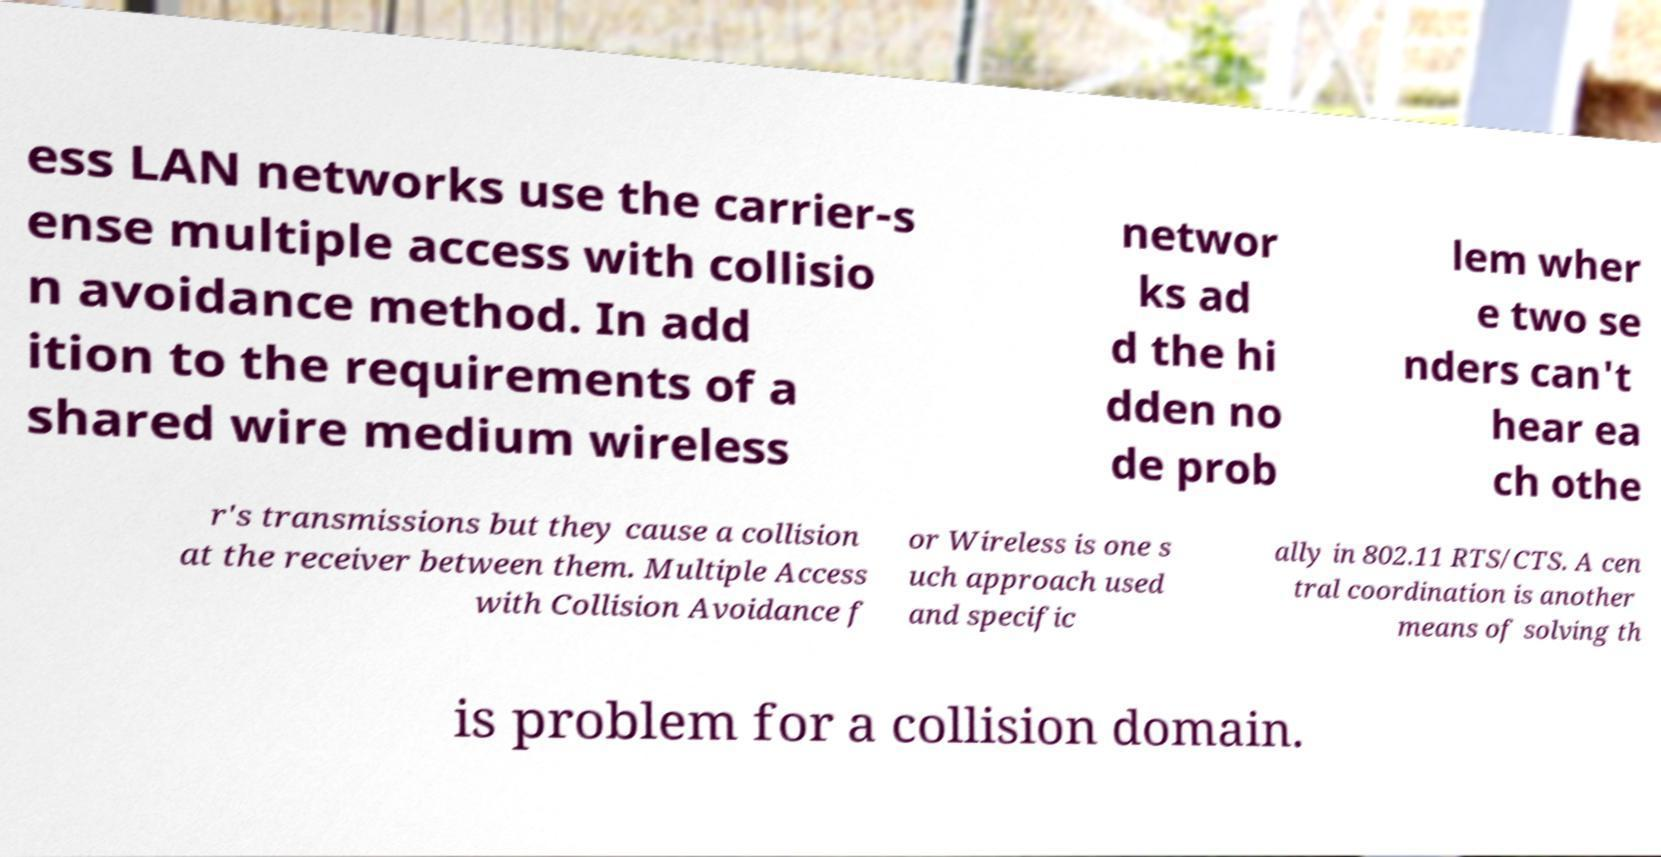There's text embedded in this image that I need extracted. Can you transcribe it verbatim? ess LAN networks use the carrier-s ense multiple access with collisio n avoidance method. In add ition to the requirements of a shared wire medium wireless networ ks ad d the hi dden no de prob lem wher e two se nders can't hear ea ch othe r's transmissions but they cause a collision at the receiver between them. Multiple Access with Collision Avoidance f or Wireless is one s uch approach used and specific ally in 802.11 RTS/CTS. A cen tral coordination is another means of solving th is problem for a collision domain. 